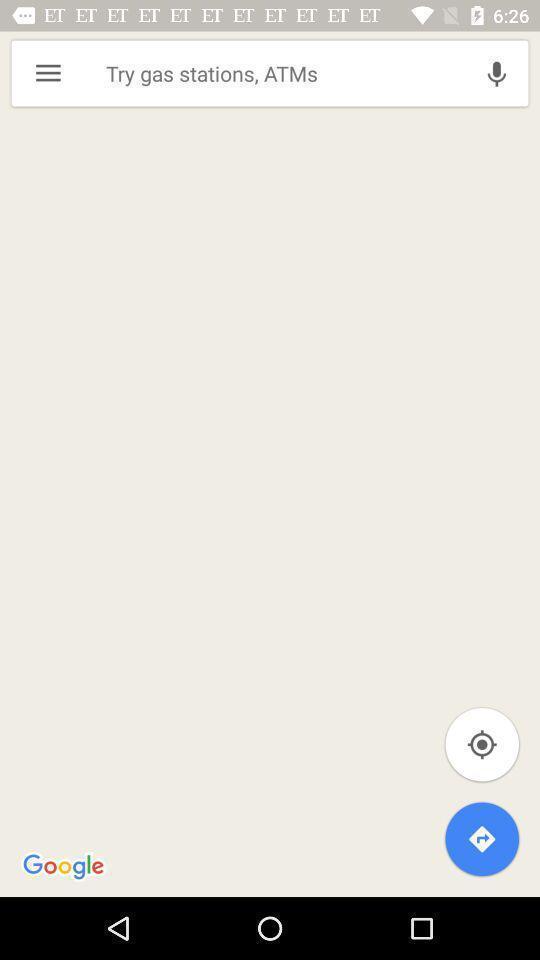Please provide a description for this image. Search bar to search a location on map. 